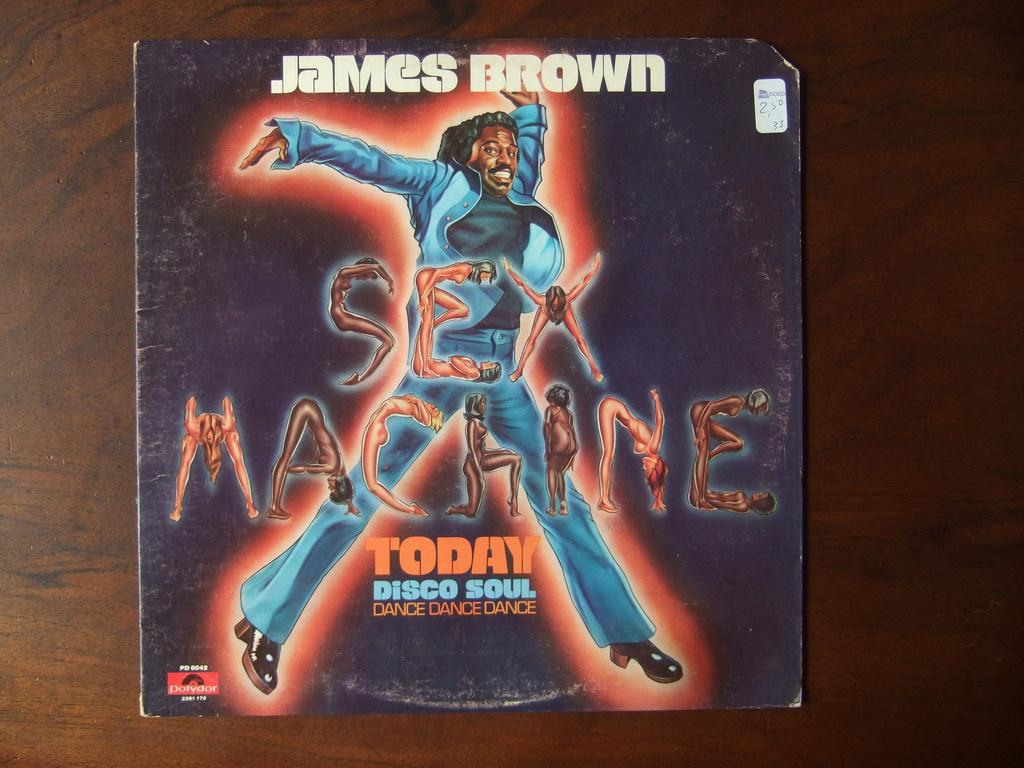<image>
Present a compact description of the photo's key features. A black cover with James Brown and today disco soul. 